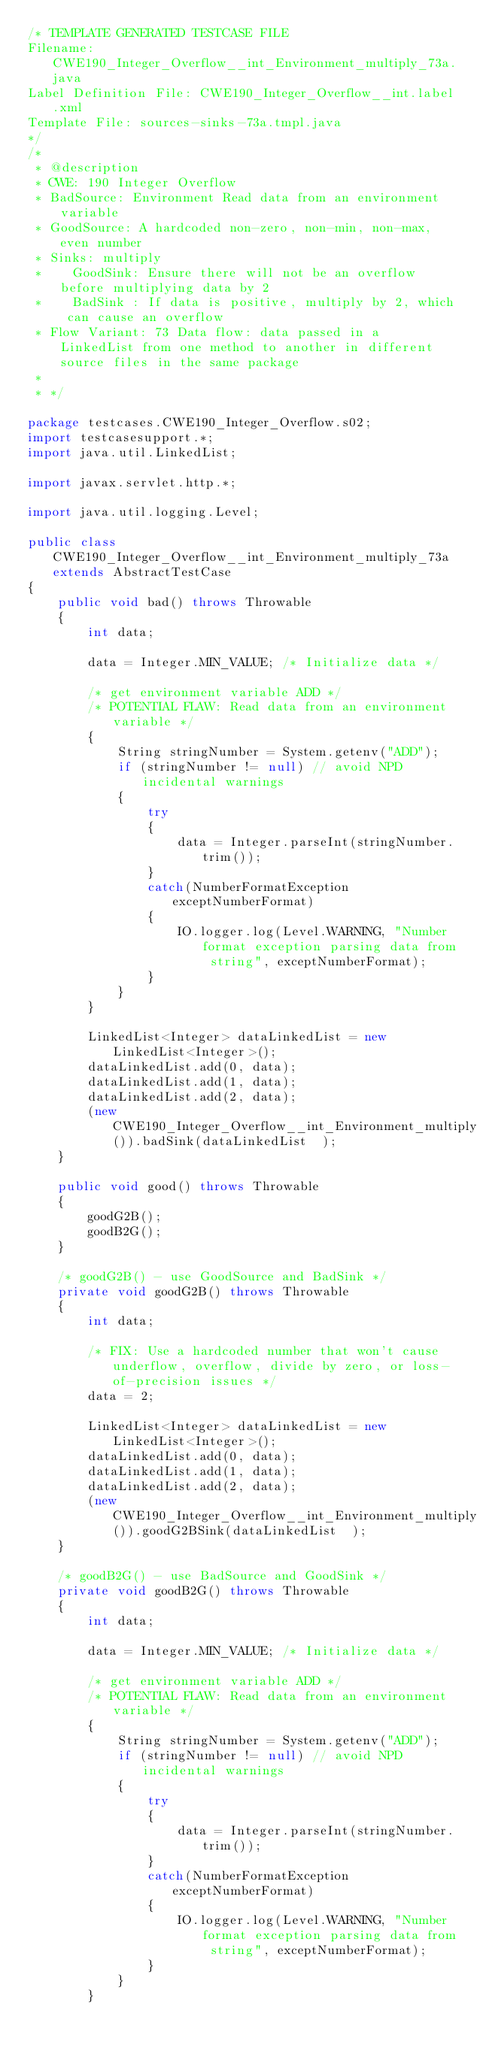Convert code to text. <code><loc_0><loc_0><loc_500><loc_500><_Java_>/* TEMPLATE GENERATED TESTCASE FILE
Filename: CWE190_Integer_Overflow__int_Environment_multiply_73a.java
Label Definition File: CWE190_Integer_Overflow__int.label.xml
Template File: sources-sinks-73a.tmpl.java
*/
/*
 * @description
 * CWE: 190 Integer Overflow
 * BadSource: Environment Read data from an environment variable
 * GoodSource: A hardcoded non-zero, non-min, non-max, even number
 * Sinks: multiply
 *    GoodSink: Ensure there will not be an overflow before multiplying data by 2
 *    BadSink : If data is positive, multiply by 2, which can cause an overflow
 * Flow Variant: 73 Data flow: data passed in a LinkedList from one method to another in different source files in the same package
 *
 * */

package testcases.CWE190_Integer_Overflow.s02;
import testcasesupport.*;
import java.util.LinkedList;

import javax.servlet.http.*;

import java.util.logging.Level;

public class CWE190_Integer_Overflow__int_Environment_multiply_73a extends AbstractTestCase
{
    public void bad() throws Throwable
    {
        int data;

        data = Integer.MIN_VALUE; /* Initialize data */

        /* get environment variable ADD */
        /* POTENTIAL FLAW: Read data from an environment variable */
        {
            String stringNumber = System.getenv("ADD");
            if (stringNumber != null) // avoid NPD incidental warnings
            {
                try
                {
                    data = Integer.parseInt(stringNumber.trim());
                }
                catch(NumberFormatException exceptNumberFormat)
                {
                    IO.logger.log(Level.WARNING, "Number format exception parsing data from string", exceptNumberFormat);
                }
            }
        }

        LinkedList<Integer> dataLinkedList = new LinkedList<Integer>();
        dataLinkedList.add(0, data);
        dataLinkedList.add(1, data);
        dataLinkedList.add(2, data);
        (new CWE190_Integer_Overflow__int_Environment_multiply_73b()).badSink(dataLinkedList  );
    }

    public void good() throws Throwable
    {
        goodG2B();
        goodB2G();
    }

    /* goodG2B() - use GoodSource and BadSink */
    private void goodG2B() throws Throwable
    {
        int data;

        /* FIX: Use a hardcoded number that won't cause underflow, overflow, divide by zero, or loss-of-precision issues */
        data = 2;

        LinkedList<Integer> dataLinkedList = new LinkedList<Integer>();
        dataLinkedList.add(0, data);
        dataLinkedList.add(1, data);
        dataLinkedList.add(2, data);
        (new CWE190_Integer_Overflow__int_Environment_multiply_73b()).goodG2BSink(dataLinkedList  );
    }

    /* goodB2G() - use BadSource and GoodSink */
    private void goodB2G() throws Throwable
    {
        int data;

        data = Integer.MIN_VALUE; /* Initialize data */

        /* get environment variable ADD */
        /* POTENTIAL FLAW: Read data from an environment variable */
        {
            String stringNumber = System.getenv("ADD");
            if (stringNumber != null) // avoid NPD incidental warnings
            {
                try
                {
                    data = Integer.parseInt(stringNumber.trim());
                }
                catch(NumberFormatException exceptNumberFormat)
                {
                    IO.logger.log(Level.WARNING, "Number format exception parsing data from string", exceptNumberFormat);
                }
            }
        }
</code> 